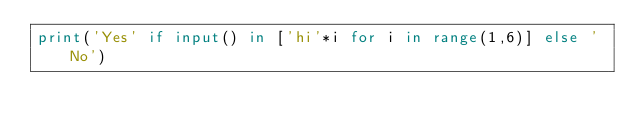Convert code to text. <code><loc_0><loc_0><loc_500><loc_500><_Python_>print('Yes' if input() in ['hi'*i for i in range(1,6)] else 'No')</code> 